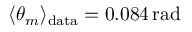<formula> <loc_0><loc_0><loc_500><loc_500>\langle \theta _ { m } \rangle _ { d a t a } = 0 . 0 8 4 \, r a d</formula> 